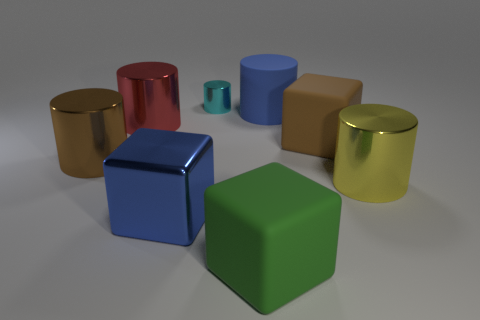Add 1 tiny green shiny objects. How many objects exist? 9 Subtract all blue rubber cylinders. How many cylinders are left? 4 Subtract 2 blocks. How many blocks are left? 1 Subtract all cylinders. How many objects are left? 3 Subtract all brown cylinders. Subtract all green spheres. How many cylinders are left? 4 Subtract all red spheres. How many blue cubes are left? 1 Subtract all metal cylinders. Subtract all purple matte spheres. How many objects are left? 4 Add 3 red shiny cylinders. How many red shiny cylinders are left? 4 Add 2 big matte cubes. How many big matte cubes exist? 4 Subtract all blue blocks. How many blocks are left? 2 